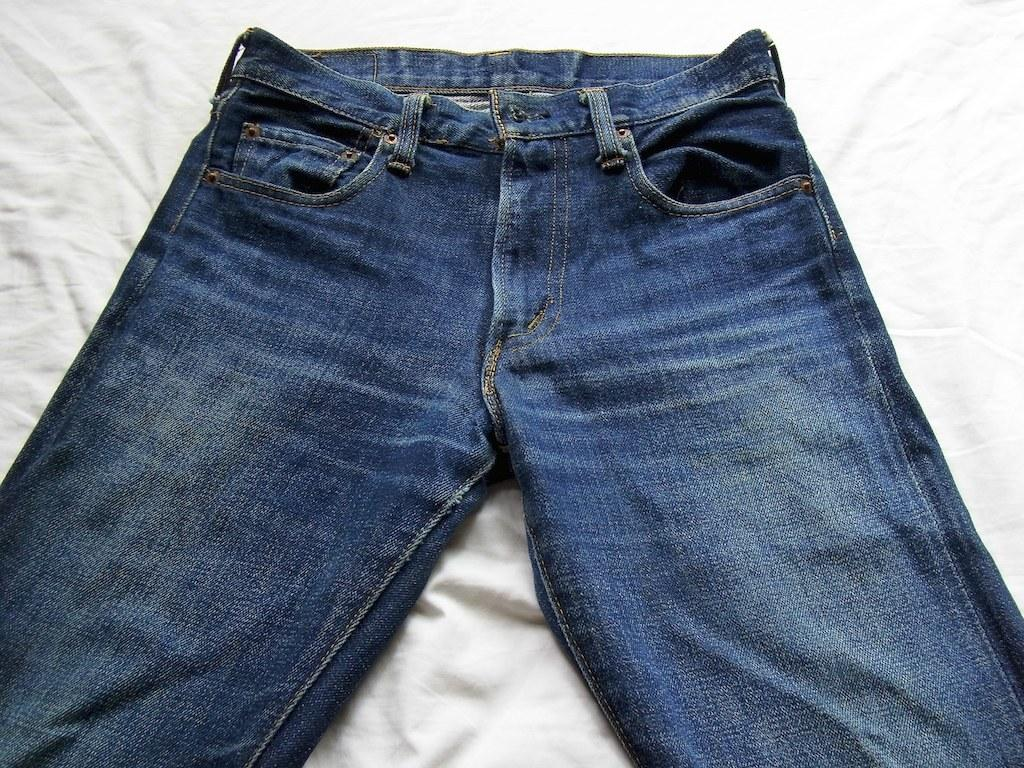What type of clothing item is in the image? There is a pair of pants in the image. What color are the pants? The pants are blue in color. How are the pants positioned in the image? The pants are placed on a white cloth. What type of dental treatment is being performed on the pants in the image? There is no dental treatment being performed on the pants in the image, as the image features a pair of blue pants placed on a white cloth. 